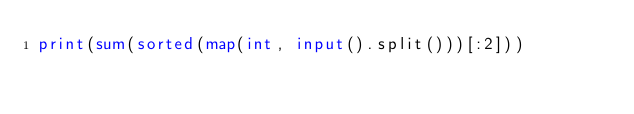Convert code to text. <code><loc_0><loc_0><loc_500><loc_500><_Python_>print(sum(sorted(map(int, input().split()))[:2]))</code> 